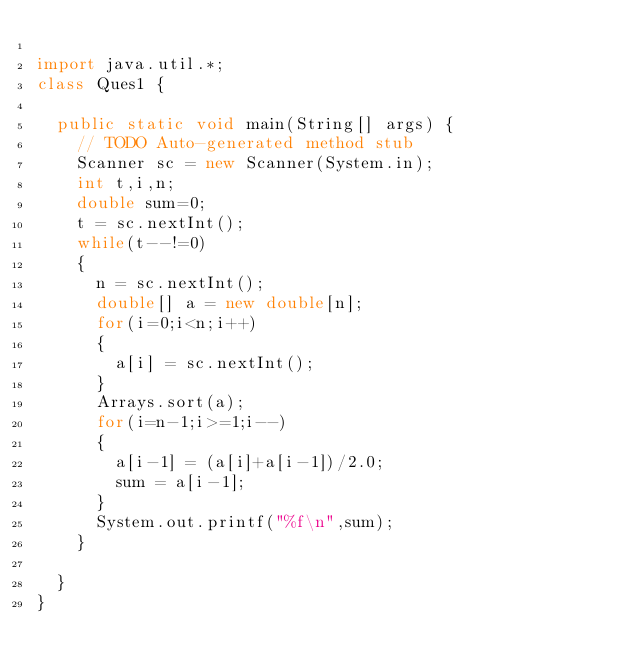<code> <loc_0><loc_0><loc_500><loc_500><_Java_>
import java.util.*;
class Ques1 {

	public static void main(String[] args) {
		// TODO Auto-generated method stub
		Scanner sc = new Scanner(System.in);
		int t,i,n;
		double sum=0;
		t = sc.nextInt();
		while(t--!=0)
		{
			n = sc.nextInt();
			double[] a = new double[n];
			for(i=0;i<n;i++)
			{
				a[i] = sc.nextInt();
			}
			Arrays.sort(a);
			for(i=n-1;i>=1;i--)
			{
				a[i-1] = (a[i]+a[i-1])/2.0;
				sum = a[i-1];
			}
			System.out.printf("%f\n",sum);
		}
		
	}
}
</code> 